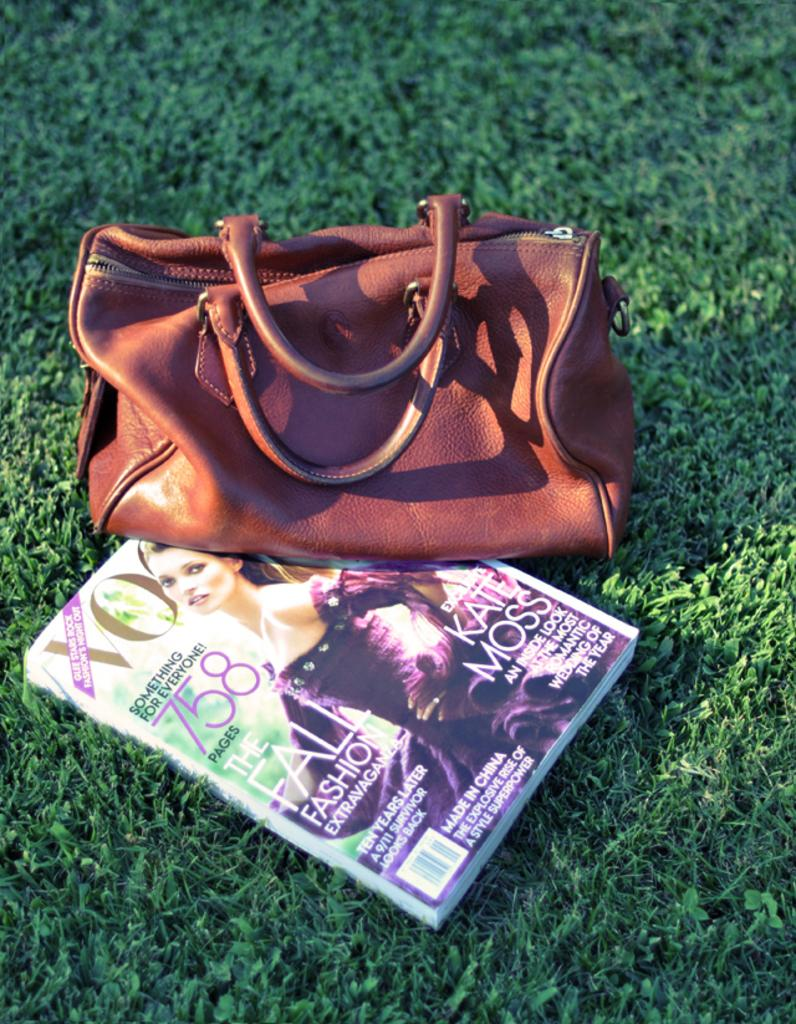What type of accessory is visible in the image? There is a brown handbag in the image. What other item can be seen in the image? There is a magazine in the image. Where is the magazine located? The magazine is on the grass. What is depicted on the magazine? There is a woman wearing a purple dress on the magazine. What type of stick is the woman holding in the image? There is no stick present in the image; the woman is depicted on the magazine, not in the actual scene. What color is the orange in the image? There is no orange present in the image; the only fruit mentioned is a woman wearing a purple dress on the magazine. 